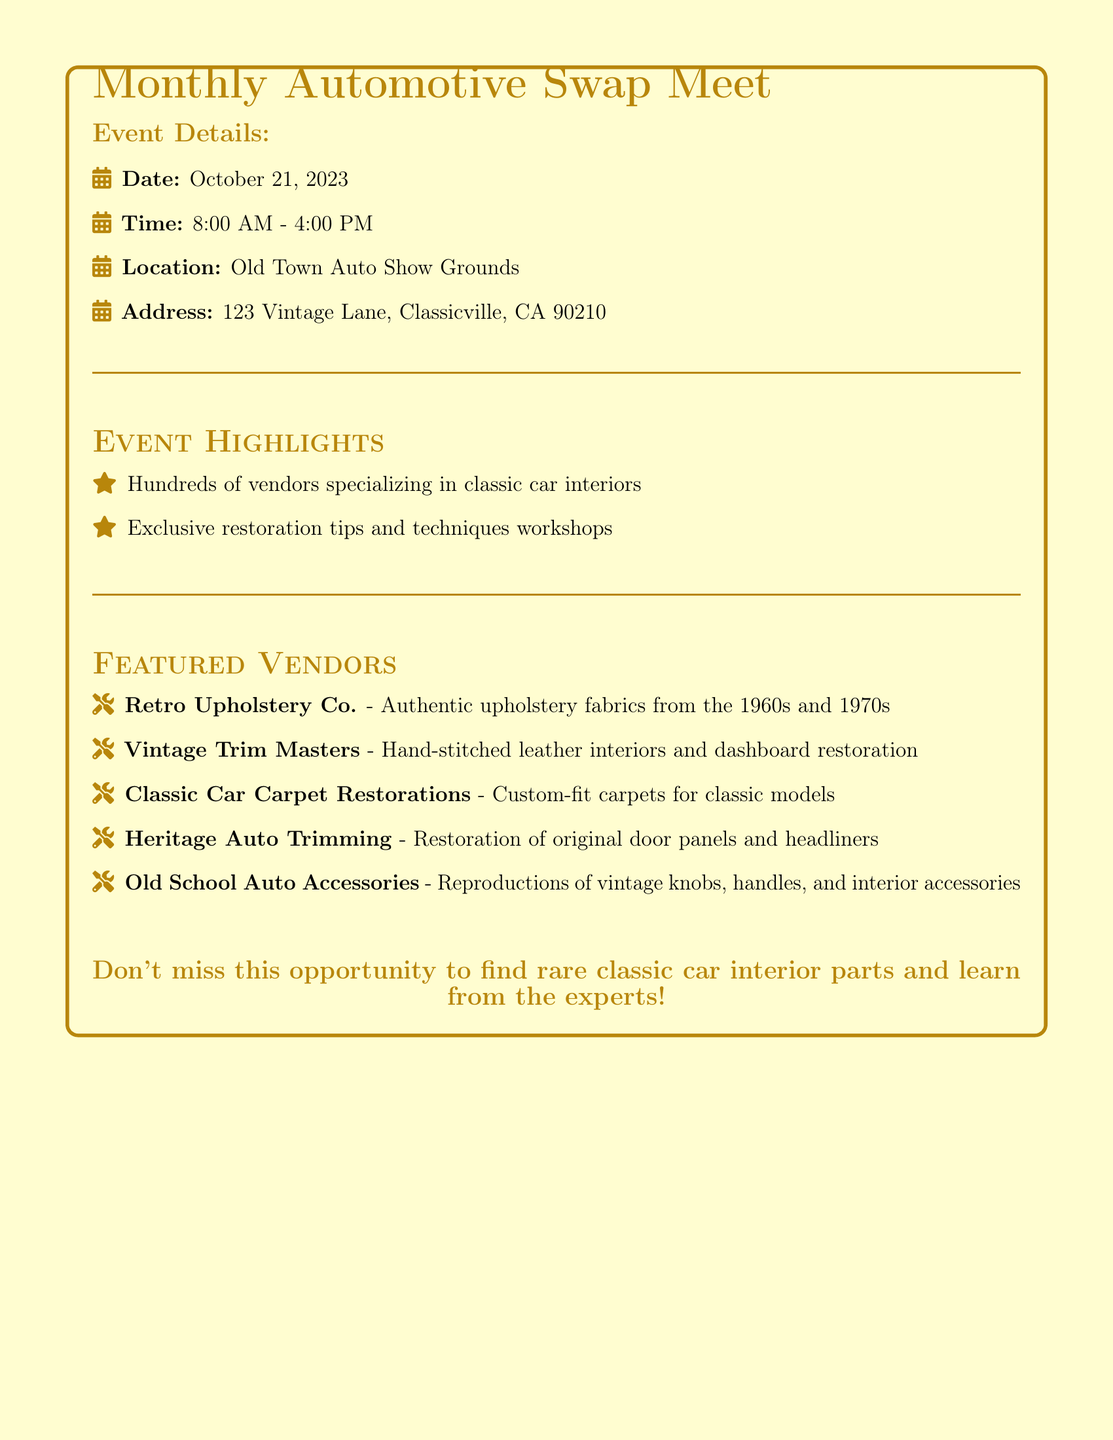What is the date of the event? The date is explicitly stated in the document as October 21, 2023.
Answer: October 21, 2023 What time does the swap meet start? The starting time is mentioned in the document under event details as 8:00 AM.
Answer: 8:00 AM What is the location of the swap meet? The location is given in the document as Old Town Auto Show Grounds.
Answer: Old Town Auto Show Grounds Which vendor specializes in hand-stitched interiors? The vendor that offers hand-stitched leather interiors is specified as Vintage Trim Masters.
Answer: Vintage Trim Masters How many hours is the swap meet open? The opening and closing times suggest that the event is open for eight hours, from 8:00 AM to 4:00 PM.
Answer: 8 hours What type of products can you find at the event? The document mentions that vendors specialize in classic car interiors and related accessories.
Answer: Classic car interiors Which vendor offers authentic upholstery from the 1960s? Retro Upholstery Co. is the vendor that provides authentic upholstery fabrics from the 1960s.
Answer: Retro Upholstery Co Is there a workshop mentioned in the event highlights? The document indicates that there will be exclusive restoration tips and techniques workshops, confirming workshops are included.
Answer: Yes, workshops What is the address of the event? The complete address is given in the document as 123 Vintage Lane, Classicville, CA 90210.
Answer: 123 Vintage Lane, Classicville, CA 90210 